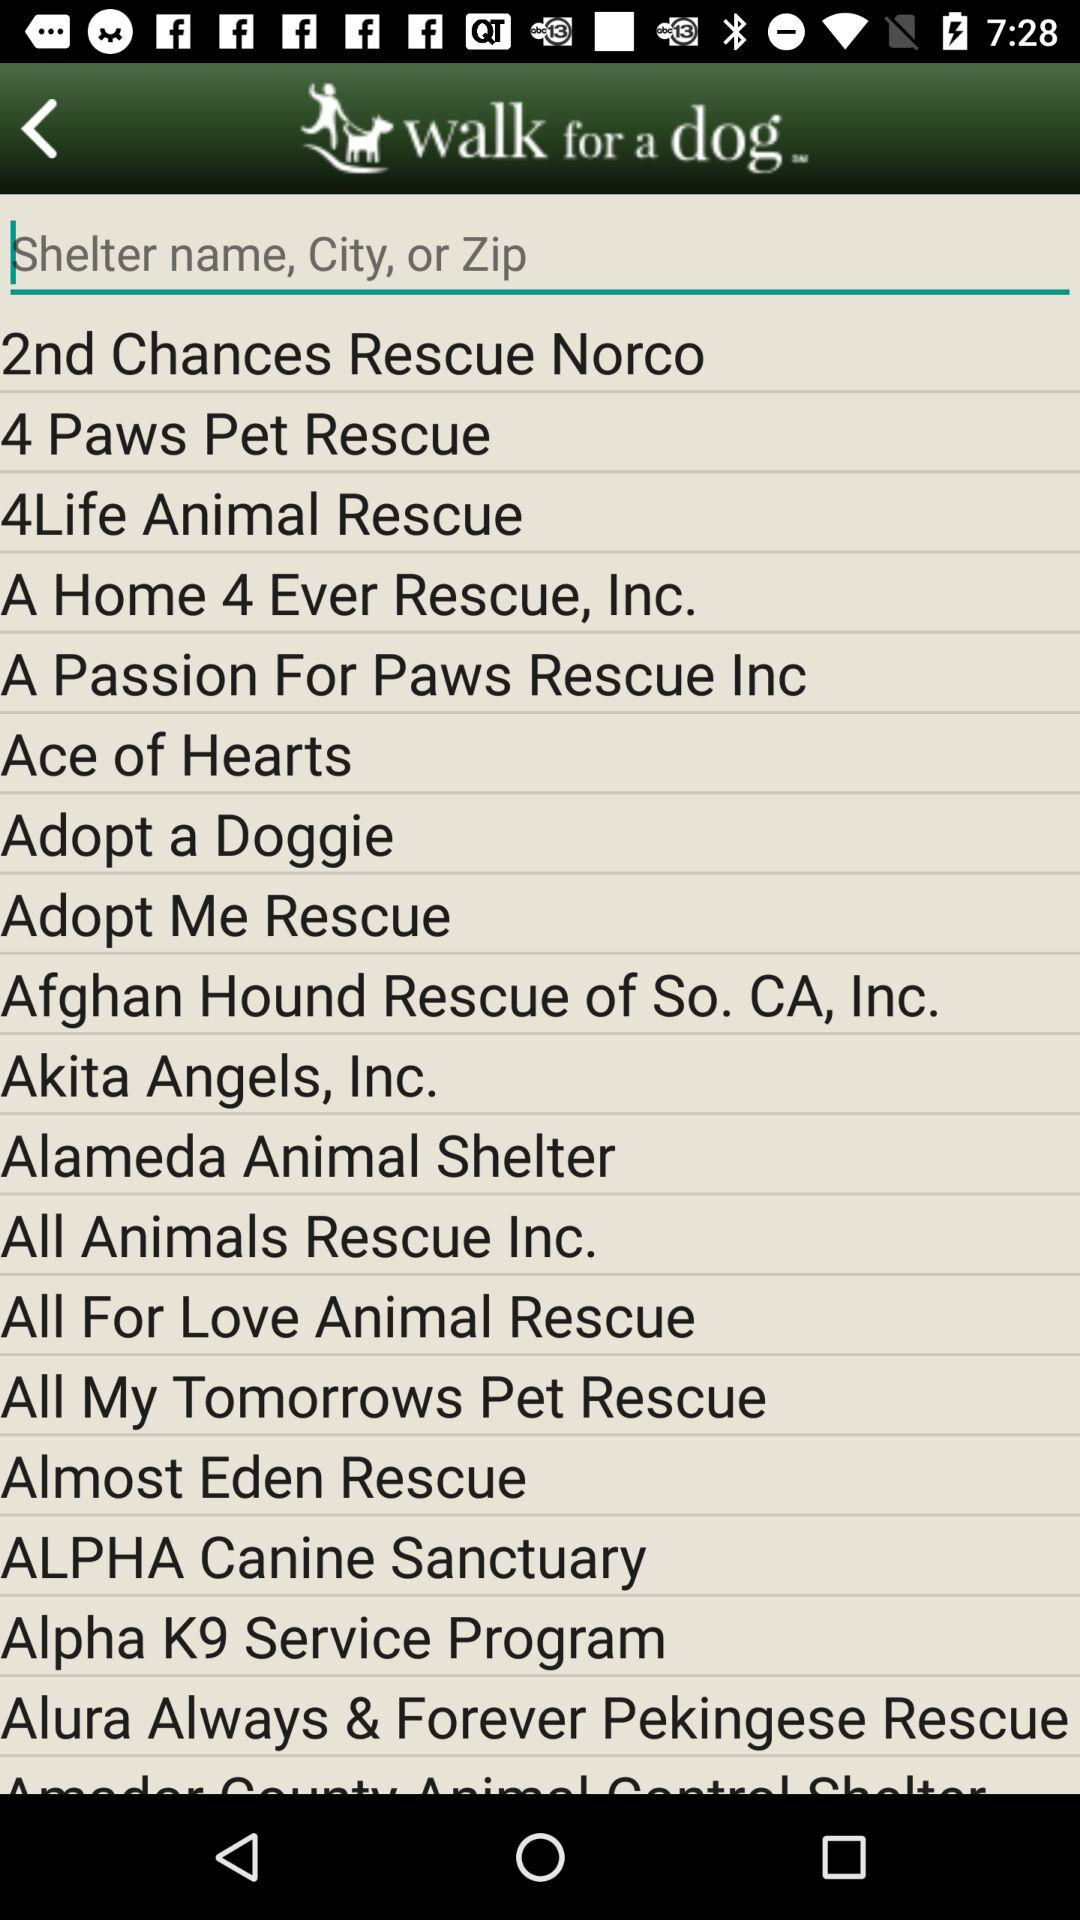What are the different shelter names available?
Answer the question using a single word or phrase. The different available shelter names are "2nd Chances Rescue Norco", "4 Paws Pet Rescue", "4Life Animal Rescue", "A Home 4 Ever Rescue, Inc.", "A Passion For Paws Rescue Inc," "Ace of Hearts", "Adopt a Doggie", "Adopt Me Rescue", "Afghan Hound Rescue of So. CA, Inc.", "Akita Angels, Inc.", "Alameda Animal Shelter", "All Animals Rescue Inc.", "All For Love Animal Rescue", "All My Tomorrows Pet Rescue", "Almost Eden Rescue", "ALPHA Canine Sanctuary", "Alpha K9 Service Program", "Alura Always & Forever Pekingese Rescue" 